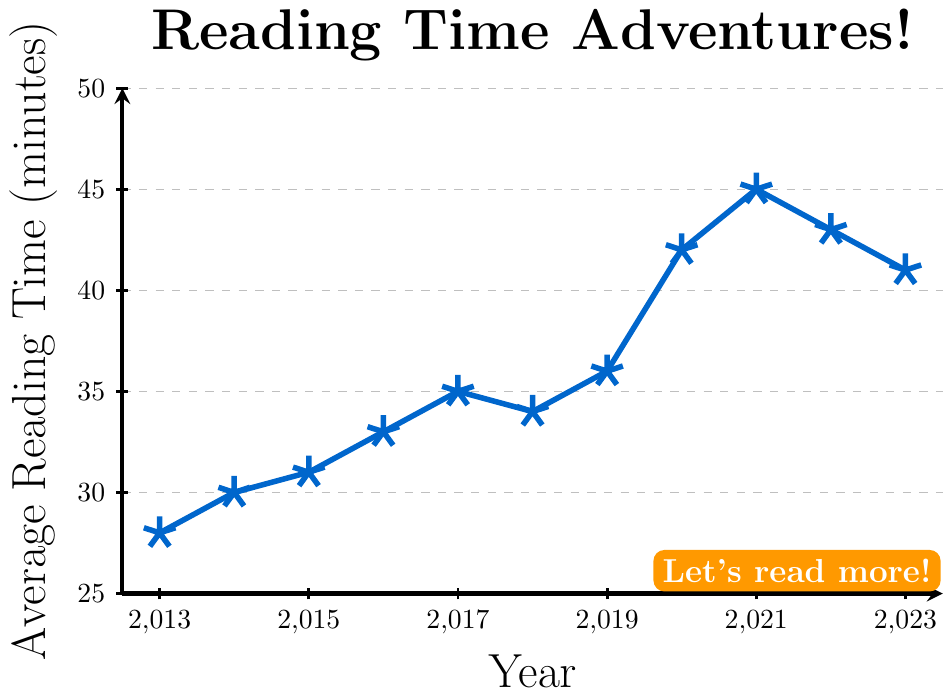What was the average reading time in 2023? The figure shows a line plot with the average reading time for each year. In 2023, the plot indicates the value.
Answer: 41 minutes Which year had the highest average reading time? To find the highest value, look at the peak of the line plot. The year with the highest point is the desired answer.
Answer: 2021 How much did the average reading time increase from 2013 to 2021? Subtract the average reading time in 2013 from the average reading time in 2021. 45 (2021) - 28 (2013) = 17 minutes
Answer: 17 minutes During which year did the average reading time first exceed 40 minutes? Look at the years starting around when the line plot first crosses the 40-minute mark.
Answer: 2020 What's the difference in average reading time between 2017 and 2022? Subtract the value for 2017 from the value for 2022. 43 (2022) - 35 (2017) = 8 minutes
Answer: 8 minutes Compare the average reading time in 2016 and 2018. Which year had more reading time? Looking at the chart, compare the values for 2016 and 2018. 33 (2016) < 34 (2018).
Answer: 2018 By how much did the average reading time change from 2018 to 2019? Subtract the average reading time in 2018 from the average reading time in 2019. 36 (2019) - 34 (2018) = 2 minutes
Answer: 2 minutes Between which consecutive years did the average reading time show the greatest increase? Observe the differences between consecutive yearly values. The greatest increase is between 2019 and 2020 (42 - 36 = 6 minutes).
Answer: 2019 and 2020 What trend do you notice about the average reading time from 2013 to 2021? From 2013 to 2021, the overall trend is an increase, with a peak in 2021 before decreasing slightly.
Answer: Increasing trend If the reading time continued to decrease after 2023, what might the value be in 2024, assuming a steady decrease similar to 2022 to 2023? From 2022 to 2023, the decrease is 2 minutes (43 - 41). Assuming a similar decrease, 41 (2023) - 2 = 39 minutes for 2024.
Answer: 39 minutes 